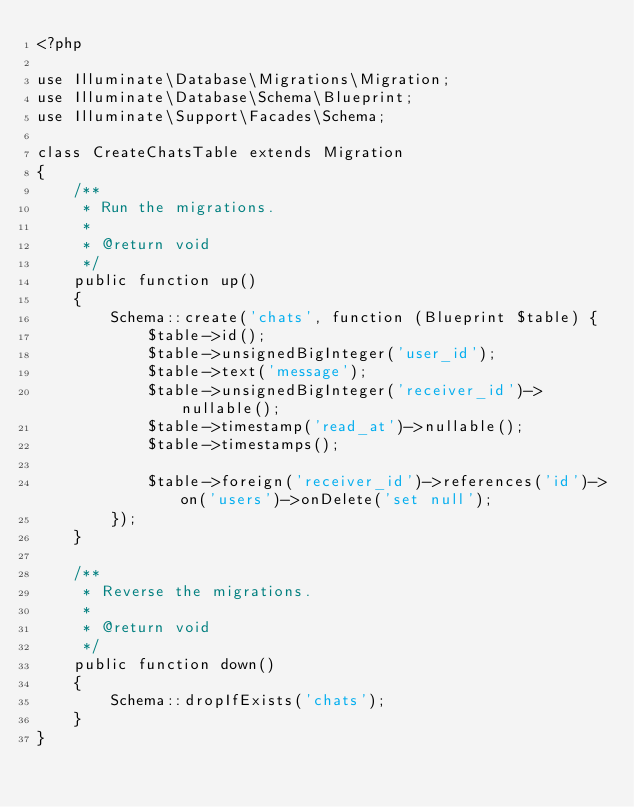<code> <loc_0><loc_0><loc_500><loc_500><_PHP_><?php

use Illuminate\Database\Migrations\Migration;
use Illuminate\Database\Schema\Blueprint;
use Illuminate\Support\Facades\Schema;

class CreateChatsTable extends Migration
{
    /**
     * Run the migrations.
     *
     * @return void
     */
    public function up()
    {
        Schema::create('chats', function (Blueprint $table) {
            $table->id();
            $table->unsignedBigInteger('user_id');
            $table->text('message');
            $table->unsignedBigInteger('receiver_id')->nullable();
            $table->timestamp('read_at')->nullable();
            $table->timestamps();

            $table->foreign('receiver_id')->references('id')->on('users')->onDelete('set null');
        });
    }

    /**
     * Reverse the migrations.
     *
     * @return void
     */
    public function down()
    {
        Schema::dropIfExists('chats');
    }
}
</code> 